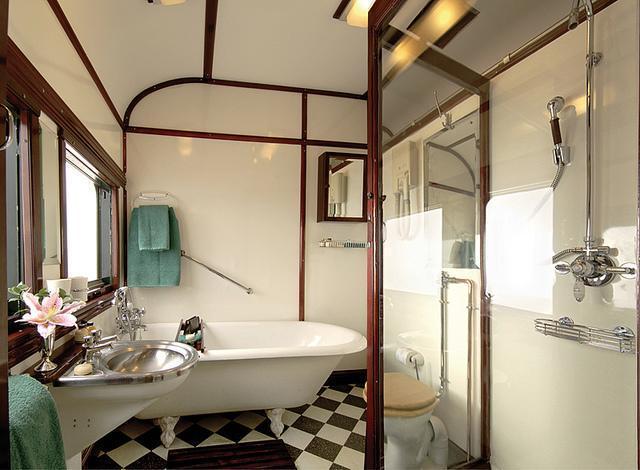How many people are walking a dog?
Give a very brief answer. 0. 